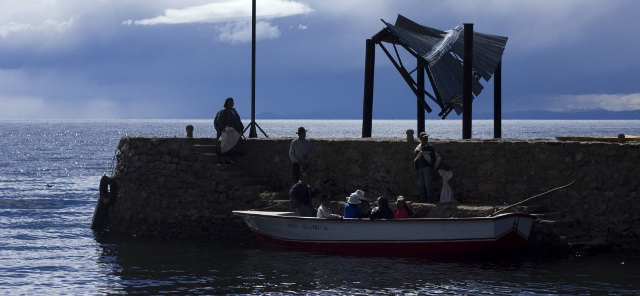<image>What country does the flag represent? There is no flag in the image. However, it could represent the USA, Mexico, or India. What material was the boats made of? It is not clear what material the boats were made of. It could be metal, fiberglass, wood or aluminum. What country does the flag represent? There is no flag in the image. What material was the boats made of? I am not sure what material the boats were made of. It can be seen that they were made of metal, fiberglass, wood, or aluminum. 